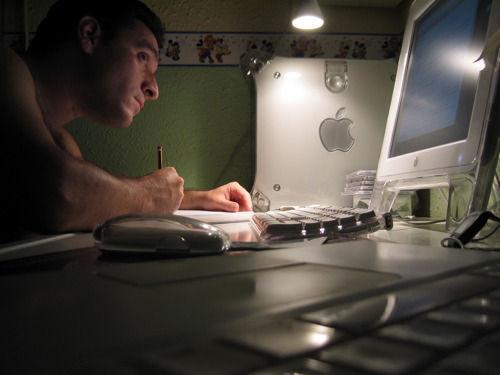How many keyboards are visible?
Give a very brief answer. 2. How many chairs are navy blue?
Give a very brief answer. 0. 